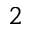<formula> <loc_0><loc_0><loc_500><loc_500>_ { 2 }</formula> 